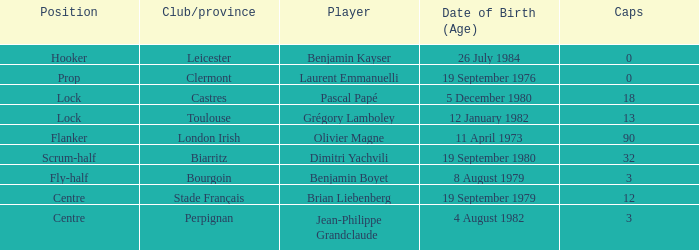Which player has a cap larger than 12 and Clubs of Toulouse? Grégory Lamboley. 